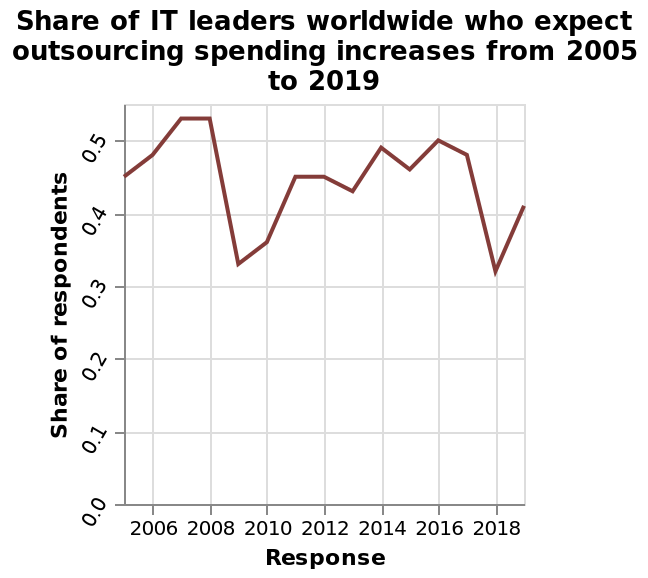<image>
please summary the statistics and relations of the chart The amount of Share of IT leaders worldwide who expect outsourcing spending increases has fluctuated between 2005 and 2019, however has returned to a similar statistic of 2005 (just over 0.4). The amount heightened to around 0.525 in 2007-2008, and dropped o.325 in 2009. What does the y-axis measure in the line diagram? The y-axis measures the share of respondents in the line diagram. What is the specific topic being depicted in the line diagram? The line diagram is depicting the share of IT leaders worldwide who expect outsourcing spending increases. 